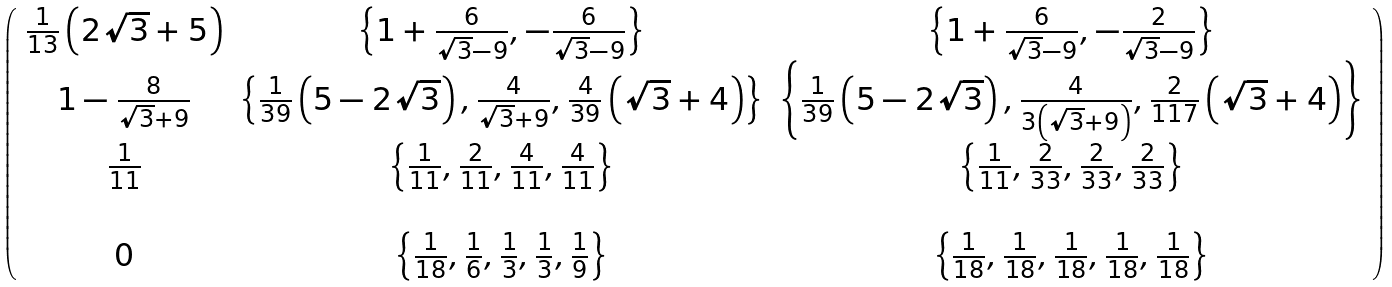Convert formula to latex. <formula><loc_0><loc_0><loc_500><loc_500>\left ( \begin{array} { c c c } \frac { 1 } { 1 3 } \left ( 2 \sqrt { 3 } + 5 \right ) & \left \{ 1 + \frac { 6 } { \sqrt { 3 } - 9 } , - \frac { 6 } { \sqrt { 3 } - 9 } \right \} & \left \{ 1 + \frac { 6 } { \sqrt { 3 } - 9 } , - \frac { 2 } { \sqrt { 3 } - 9 } \right \} \\ 1 - \frac { 8 } { \sqrt { 3 } + 9 } & \left \{ \frac { 1 } { 3 9 } \left ( 5 - 2 \sqrt { 3 } \right ) , \frac { 4 } { \sqrt { 3 } + 9 } , \frac { 4 } { 3 9 } \left ( \sqrt { 3 } + 4 \right ) \right \} & \left \{ \frac { 1 } { 3 9 } \left ( 5 - 2 \sqrt { 3 } \right ) , \frac { 4 } { 3 \left ( \sqrt { 3 } + 9 \right ) } , \frac { 2 } { 1 1 7 } \left ( \sqrt { 3 } + 4 \right ) \right \} \\ \frac { 1 } { 1 1 } & \left \{ \frac { 1 } { 1 1 } , \frac { 2 } { 1 1 } , \frac { 4 } { 1 1 } , \frac { 4 } { 1 1 } \right \} & \left \{ \frac { 1 } { 1 1 } , \frac { 2 } { 3 3 } , \frac { 2 } { 3 3 } , \frac { 2 } { 3 3 } \right \} \\ \\ 0 & \left \{ \frac { 1 } { 1 8 } , \frac { 1 } { 6 } , \frac { 1 } { 3 } , \frac { 1 } { 3 } , \frac { 1 } { 9 } \right \} & \left \{ \frac { 1 } { 1 8 } , \frac { 1 } { 1 8 } , \frac { 1 } { 1 8 } , \frac { 1 } { 1 8 } , \frac { 1 } { 1 8 } \right \} \\ \end{array} \right )</formula> 